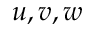Convert formula to latex. <formula><loc_0><loc_0><loc_500><loc_500>u , v , w</formula> 